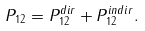<formula> <loc_0><loc_0><loc_500><loc_500>P _ { 1 2 } = P _ { 1 2 } ^ { d i r } + P _ { 1 2 } ^ { i n d i r } .</formula> 